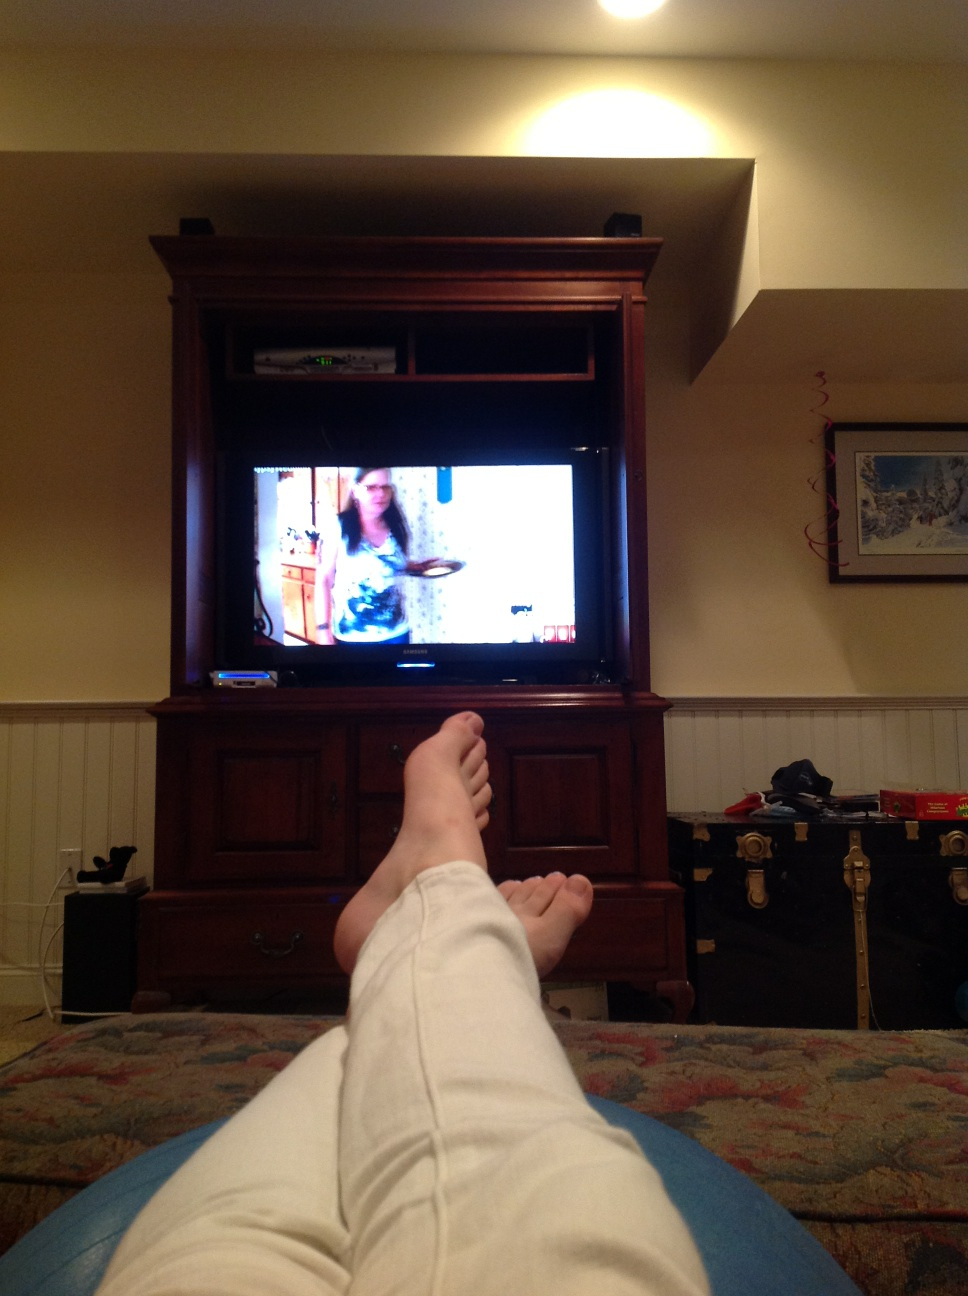What's the theme of the room as shown in the image? The room's theme looks cozy and lived-in, with a neutral color palette, a comfortable couch, homey decorations, and a television indicating it's a living or family room. 